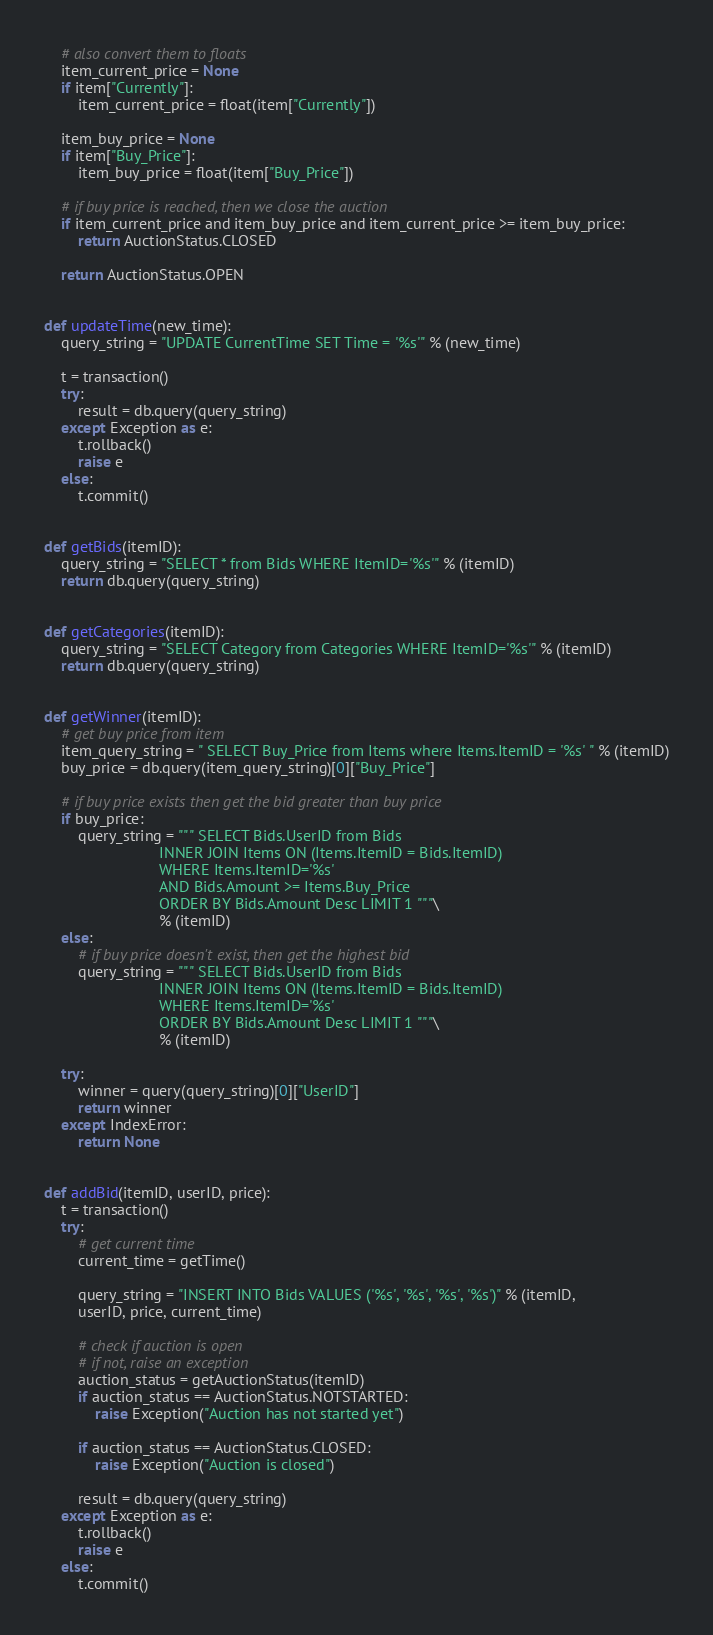Convert code to text. <code><loc_0><loc_0><loc_500><loc_500><_Python_>    # also convert them to floats
    item_current_price = None
    if item["Currently"]:
        item_current_price = float(item["Currently"])

    item_buy_price = None
    if item["Buy_Price"]:
        item_buy_price = float(item["Buy_Price"])

    # if buy price is reached, then we close the auction
    if item_current_price and item_buy_price and item_current_price >= item_buy_price:
        return AuctionStatus.CLOSED

    return AuctionStatus.OPEN


def updateTime(new_time):
    query_string = "UPDATE CurrentTime SET Time = '%s'" % (new_time)

    t = transaction()
    try:
        result = db.query(query_string)
    except Exception as e:
        t.rollback()
        raise e
    else:
        t.commit()


def getBids(itemID):
    query_string = "SELECT * from Bids WHERE ItemID='%s'" % (itemID)
    return db.query(query_string)


def getCategories(itemID):
    query_string = "SELECT Category from Categories WHERE ItemID='%s'" % (itemID)
    return db.query(query_string)


def getWinner(itemID):
    # get buy price from item
    item_query_string = " SELECT Buy_Price from Items where Items.ItemID = '%s' " % (itemID)
    buy_price = db.query(item_query_string)[0]["Buy_Price"]

    # if buy price exists then get the bid greater than buy price
    if buy_price:
        query_string = """ SELECT Bids.UserID from Bids
                           INNER JOIN Items ON (Items.ItemID = Bids.ItemID)
                           WHERE Items.ItemID='%s'
                           AND Bids.Amount >= Items.Buy_Price
                           ORDER BY Bids.Amount Desc LIMIT 1 """\
                           % (itemID)
    else:
        # if buy price doesn't exist, then get the highest bid
        query_string = """ SELECT Bids.UserID from Bids
                           INNER JOIN Items ON (Items.ItemID = Bids.ItemID)
                           WHERE Items.ItemID='%s'
                           ORDER BY Bids.Amount Desc LIMIT 1 """\
                           % (itemID)

    try:
        winner = query(query_string)[0]["UserID"]
        return winner
    except IndexError:
        return None


def addBid(itemID, userID, price):
    t = transaction()
    try:
        # get current time
        current_time = getTime()

        query_string = "INSERT INTO Bids VALUES ('%s', '%s', '%s', '%s')" % (itemID,
        userID, price, current_time)

        # check if auction is open
        # if not, raise an exception
        auction_status = getAuctionStatus(itemID)
        if auction_status == AuctionStatus.NOTSTARTED:
            raise Exception("Auction has not started yet")

        if auction_status == AuctionStatus.CLOSED:
            raise Exception("Auction is closed")

        result = db.query(query_string)
    except Exception as e:
        t.rollback()
        raise e
    else:
        t.commit()
</code> 